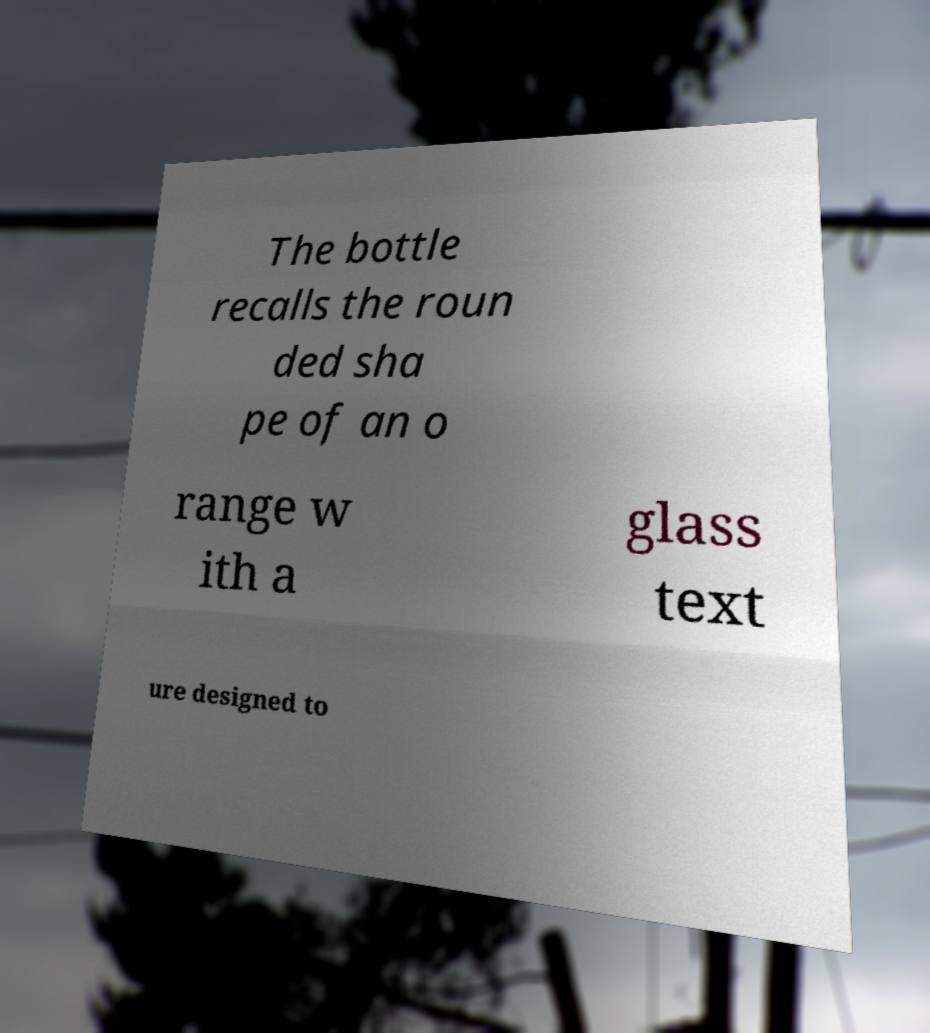Could you extract and type out the text from this image? The bottle recalls the roun ded sha pe of an o range w ith a glass text ure designed to 